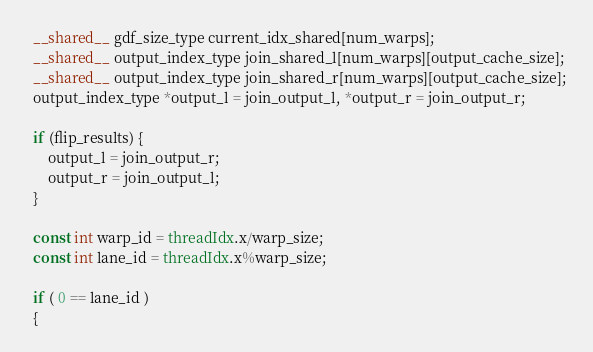Convert code to text. <code><loc_0><loc_0><loc_500><loc_500><_Cuda_>  __shared__ gdf_size_type current_idx_shared[num_warps];
  __shared__ output_index_type join_shared_l[num_warps][output_cache_size];
  __shared__ output_index_type join_shared_r[num_warps][output_cache_size];
  output_index_type *output_l = join_output_l, *output_r = join_output_r;

  if (flip_results) {
      output_l = join_output_r;
      output_r = join_output_l;
  }

  const int warp_id = threadIdx.x/warp_size;
  const int lane_id = threadIdx.x%warp_size;

  if ( 0 == lane_id )
  {</code> 